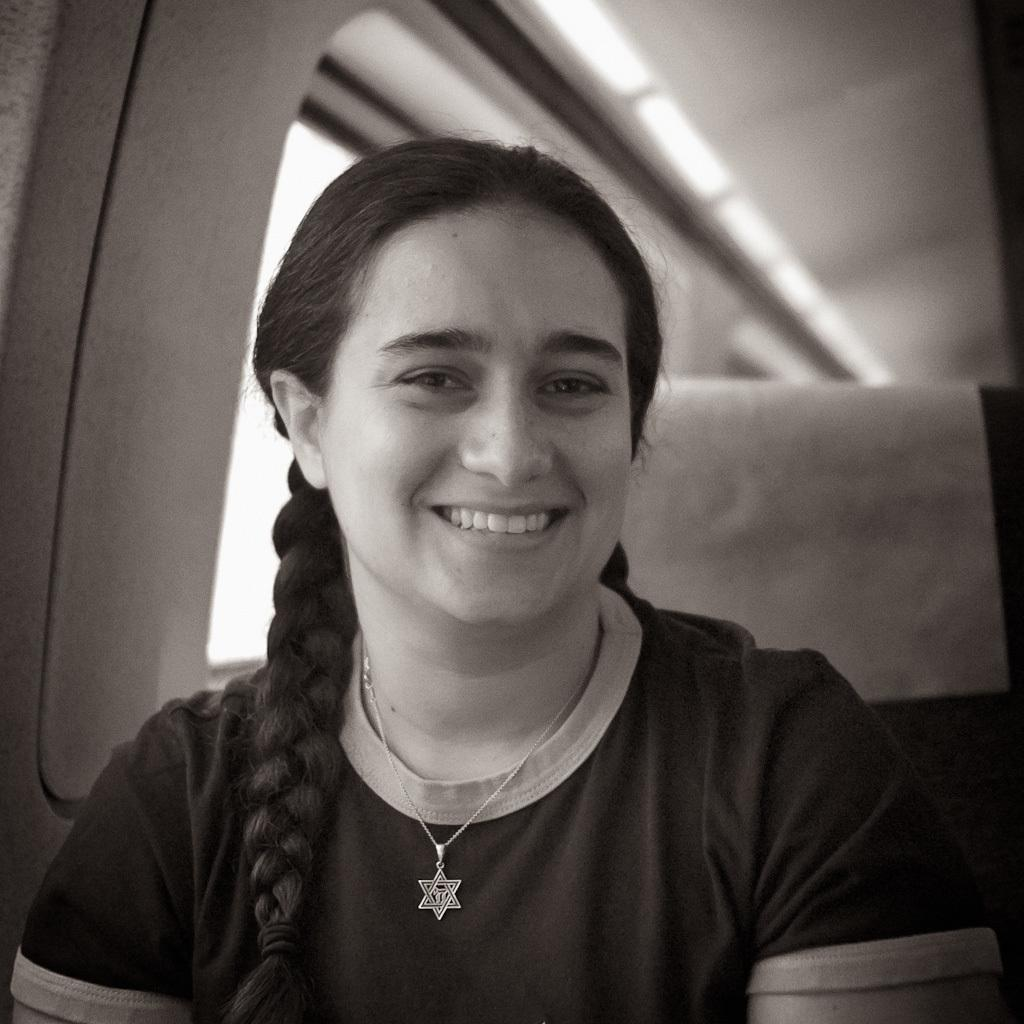Who is the main subject in the foreground of the image? There is a woman in the foreground of the image. What is the woman doing in the image? The woman is smiling. What can be seen in the background of the image? There is a window visible in the background of the image. Where do you think the image was taken? The image appears to be taken inside a vehicle. How many dogs are visible in the image? There are no dogs present in the image. What type of fan can be seen in the image? There is no fan present in the image. 